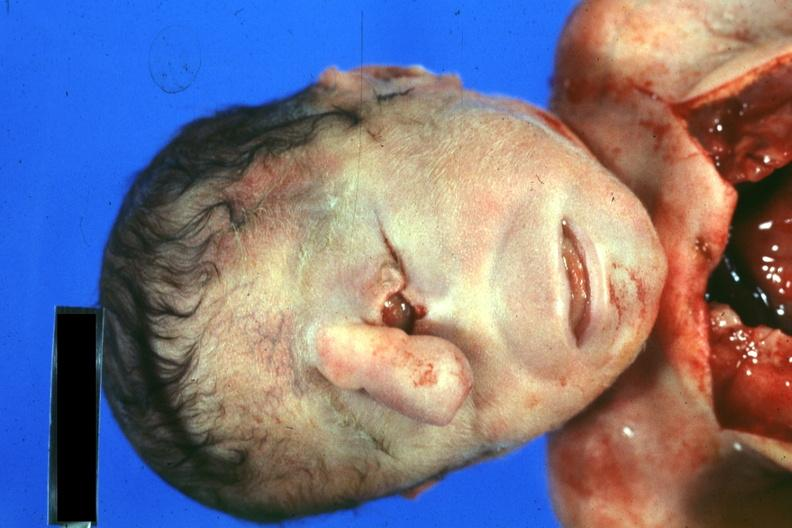what is present?
Answer the question using a single word or phrase. Cyclops 